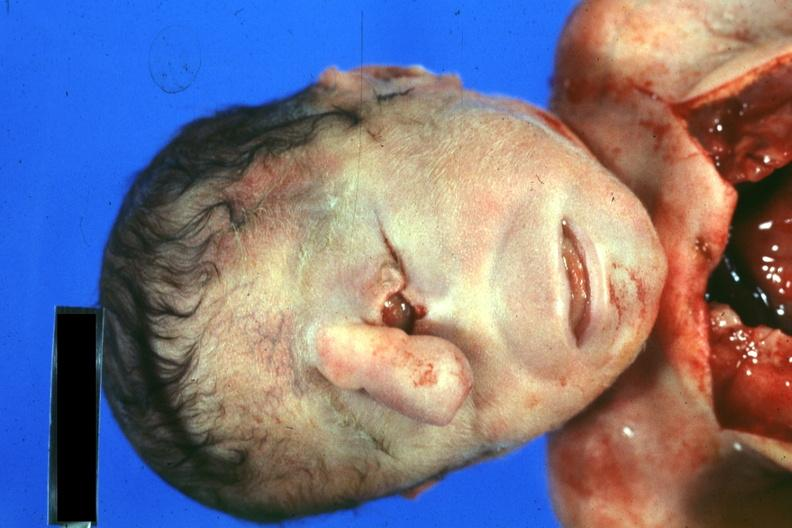what is present?
Answer the question using a single word or phrase. Cyclops 